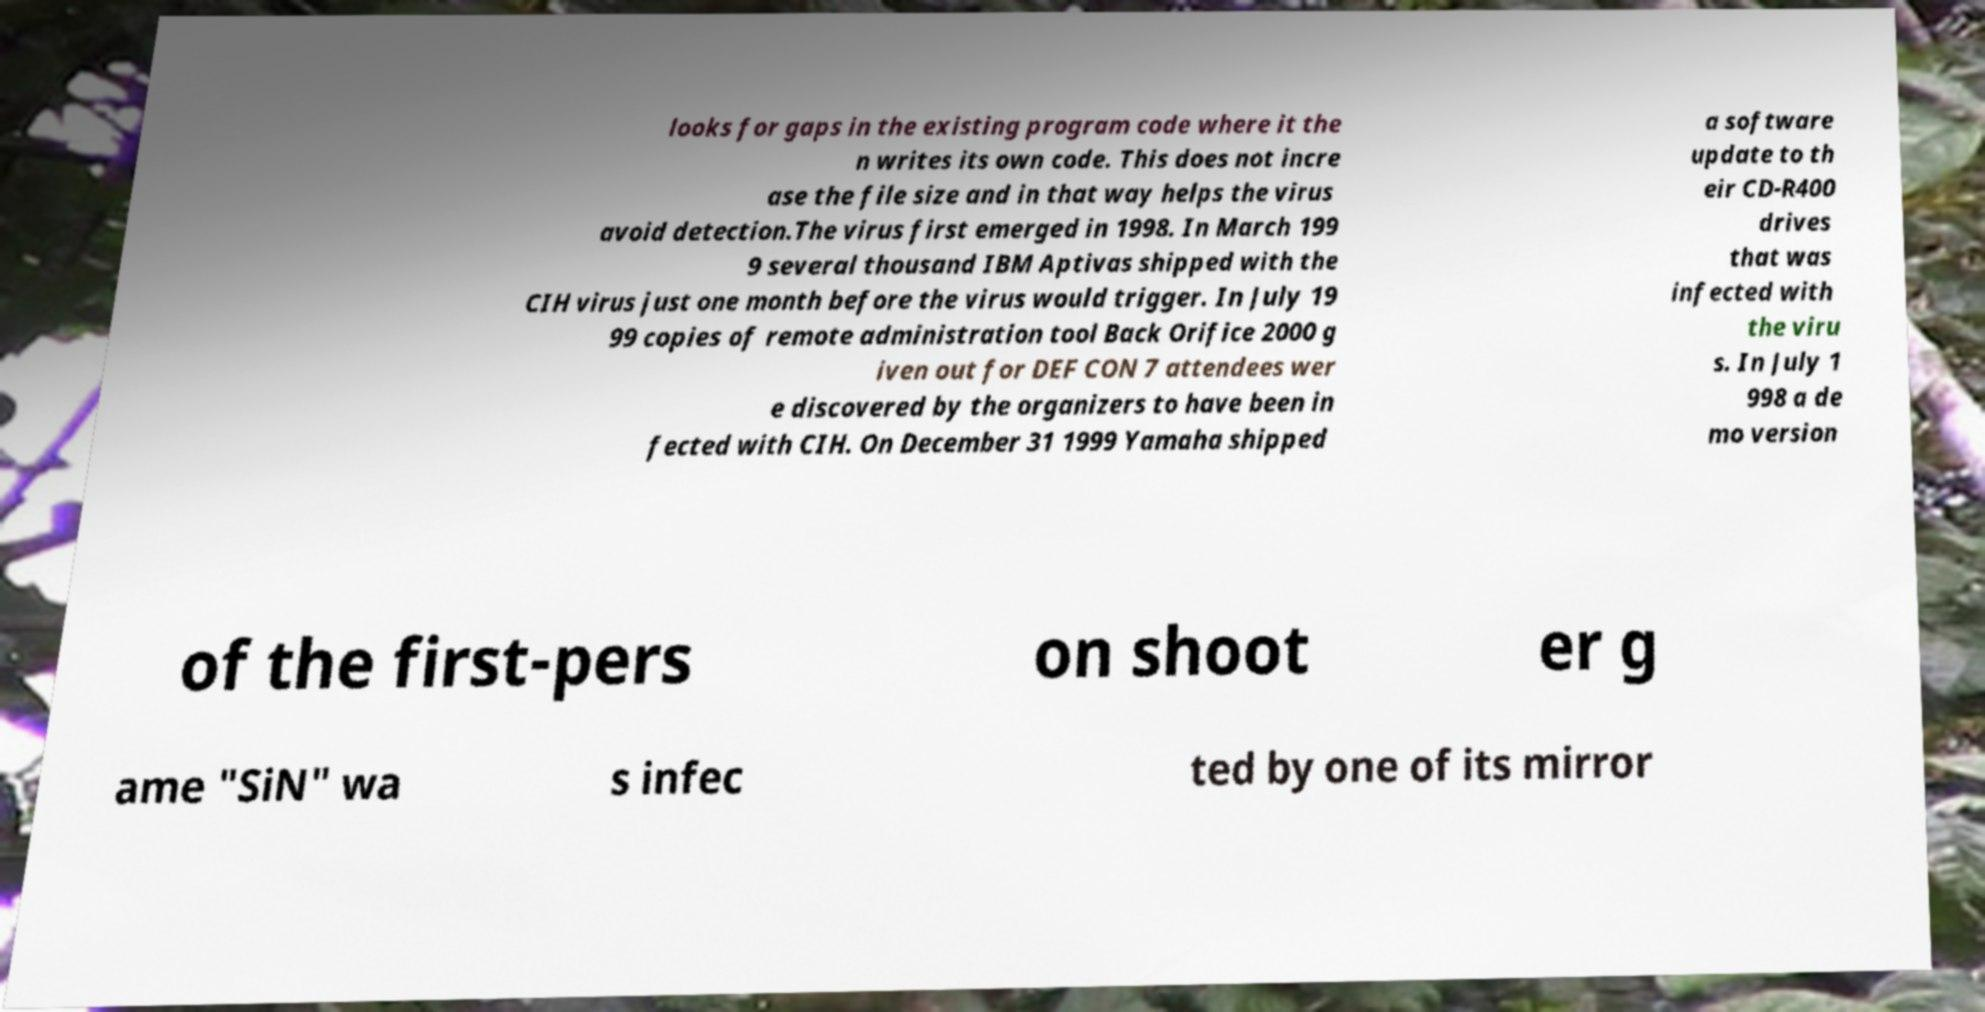Could you assist in decoding the text presented in this image and type it out clearly? looks for gaps in the existing program code where it the n writes its own code. This does not incre ase the file size and in that way helps the virus avoid detection.The virus first emerged in 1998. In March 199 9 several thousand IBM Aptivas shipped with the CIH virus just one month before the virus would trigger. In July 19 99 copies of remote administration tool Back Orifice 2000 g iven out for DEF CON 7 attendees wer e discovered by the organizers to have been in fected with CIH. On December 31 1999 Yamaha shipped a software update to th eir CD-R400 drives that was infected with the viru s. In July 1 998 a de mo version of the first-pers on shoot er g ame "SiN" wa s infec ted by one of its mirror 